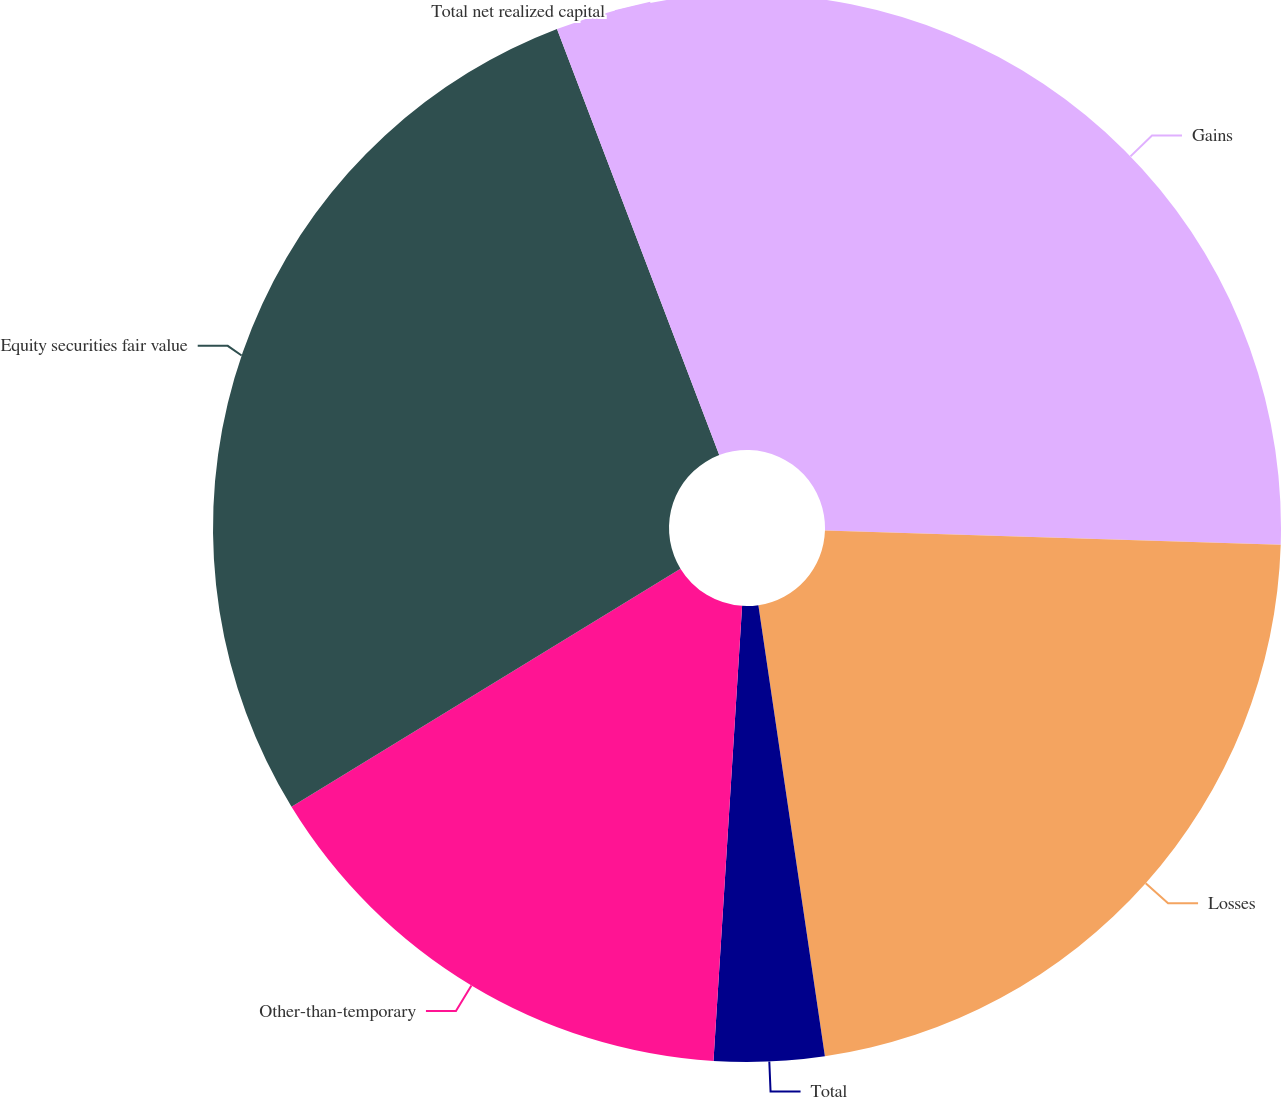<chart> <loc_0><loc_0><loc_500><loc_500><pie_chart><fcel>Gains<fcel>Losses<fcel>Total<fcel>Other-than-temporary<fcel>Equity securities fair value<fcel>Total net realized capital<nl><fcel>25.5%<fcel>22.17%<fcel>3.33%<fcel>15.26%<fcel>27.95%<fcel>5.79%<nl></chart> 